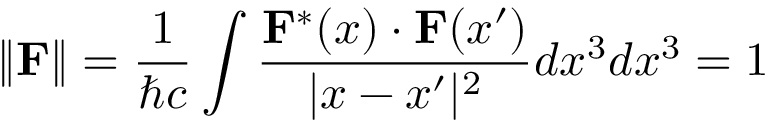Convert formula to latex. <formula><loc_0><loc_0><loc_500><loc_500>\| F \| = { \frac { 1 } { \hbar { c } } } \int { \frac { F ^ { * } ( x ) \cdot F ( x ^ { \prime } ) } { | x - x ^ { \prime } | ^ { 2 } } } d x ^ { 3 } d x ^ { 3 } = 1</formula> 